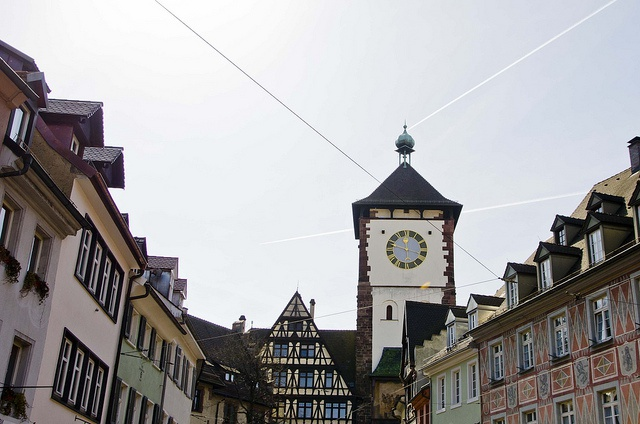Describe the objects in this image and their specific colors. I can see a clock in white, darkgray, tan, gray, and black tones in this image. 